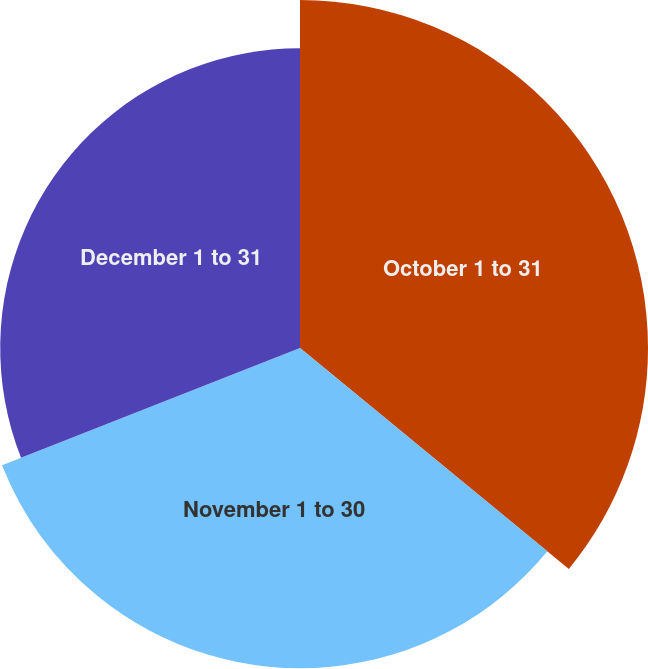Convert chart to OTSL. <chart><loc_0><loc_0><loc_500><loc_500><pie_chart><fcel>October 1 to 31<fcel>November 1 to 30<fcel>December 1 to 31<nl><fcel>35.95%<fcel>33.08%<fcel>30.97%<nl></chart> 